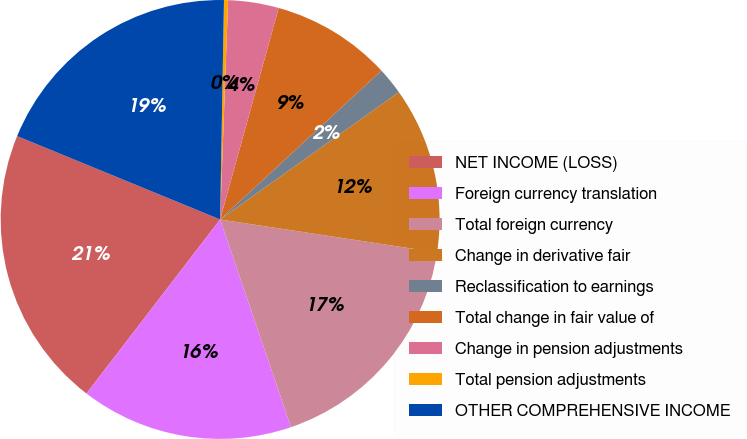Convert chart. <chart><loc_0><loc_0><loc_500><loc_500><pie_chart><fcel>NET INCOME (LOSS)<fcel>Foreign currency translation<fcel>Total foreign currency<fcel>Change in derivative fair<fcel>Reclassification to earnings<fcel>Total change in fair value of<fcel>Change in pension adjustments<fcel>Total pension adjustments<fcel>OTHER COMPREHENSIVE INCOME<nl><fcel>20.78%<fcel>15.66%<fcel>17.37%<fcel>12.25%<fcel>2.01%<fcel>8.84%<fcel>3.72%<fcel>0.3%<fcel>19.08%<nl></chart> 